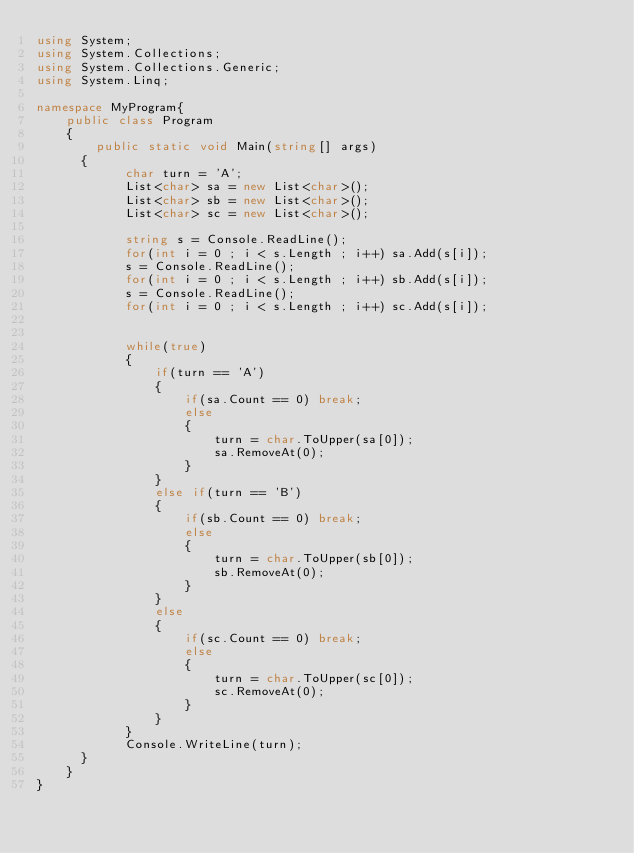<code> <loc_0><loc_0><loc_500><loc_500><_C#_>using System;
using System.Collections;
using System.Collections.Generic;
using System.Linq;

namespace MyProgram{
    public class Program
    {	
        public static void Main(string[] args)
    	{
            char turn = 'A';
            List<char> sa = new List<char>();
            List<char> sb = new List<char>();
            List<char> sc = new List<char>();
            
            string s = Console.ReadLine();
            for(int i = 0 ; i < s.Length ; i++) sa.Add(s[i]);
            s = Console.ReadLine();
            for(int i = 0 ; i < s.Length ; i++) sb.Add(s[i]);
            s = Console.ReadLine();
            for(int i = 0 ; i < s.Length ; i++) sc.Add(s[i]);
            
            
            while(true)
            {
                if(turn == 'A')
                {
                    if(sa.Count == 0) break;
                    else
                    {
                        turn = char.ToUpper(sa[0]);
                        sa.RemoveAt(0);
                    }
                }
                else if(turn == 'B')
                {
                    if(sb.Count == 0) break;
                    else
                    {
                        turn = char.ToUpper(sb[0]);
                        sb.RemoveAt(0);
                    }
                }
                else
                {
                    if(sc.Count == 0) break;
                    else
                    {
                        turn = char.ToUpper(sc[0]);
                        sc.RemoveAt(0);
                    }
                }
            }
            Console.WriteLine(turn);
    	}
    }
}</code> 